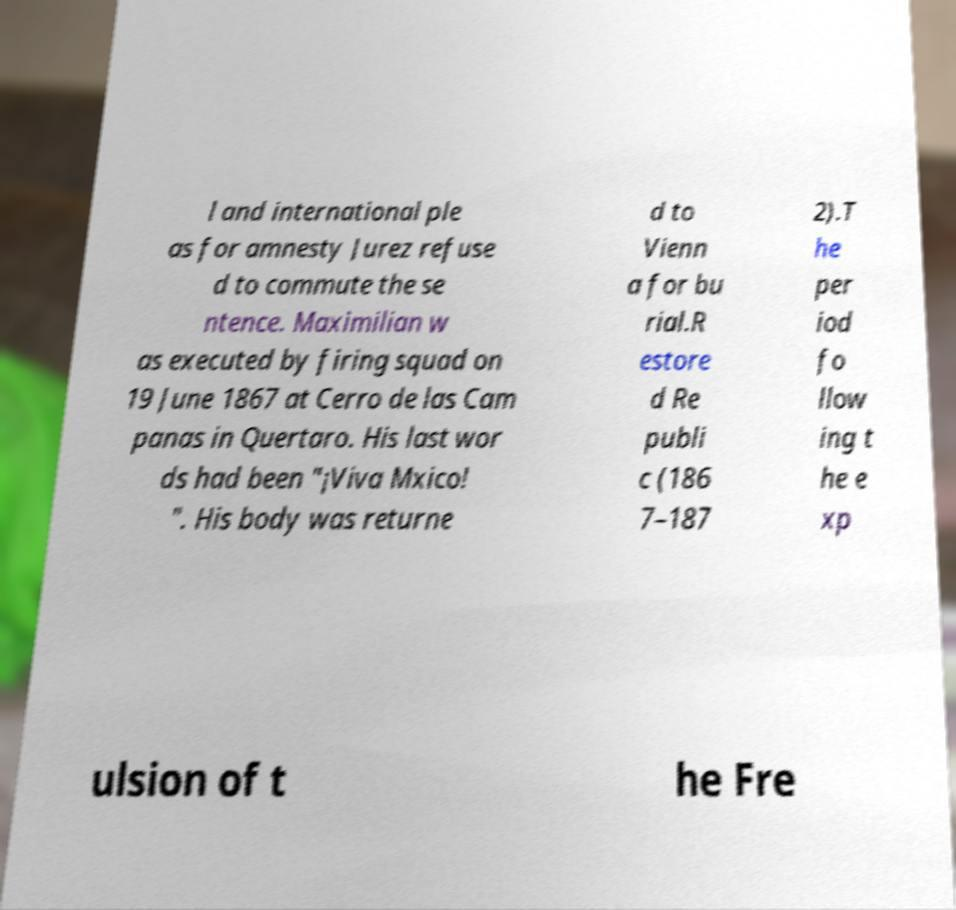I need the written content from this picture converted into text. Can you do that? l and international ple as for amnesty Jurez refuse d to commute the se ntence. Maximilian w as executed by firing squad on 19 June 1867 at Cerro de las Cam panas in Quertaro. His last wor ds had been "¡Viva Mxico! ". His body was returne d to Vienn a for bu rial.R estore d Re publi c (186 7–187 2).T he per iod fo llow ing t he e xp ulsion of t he Fre 